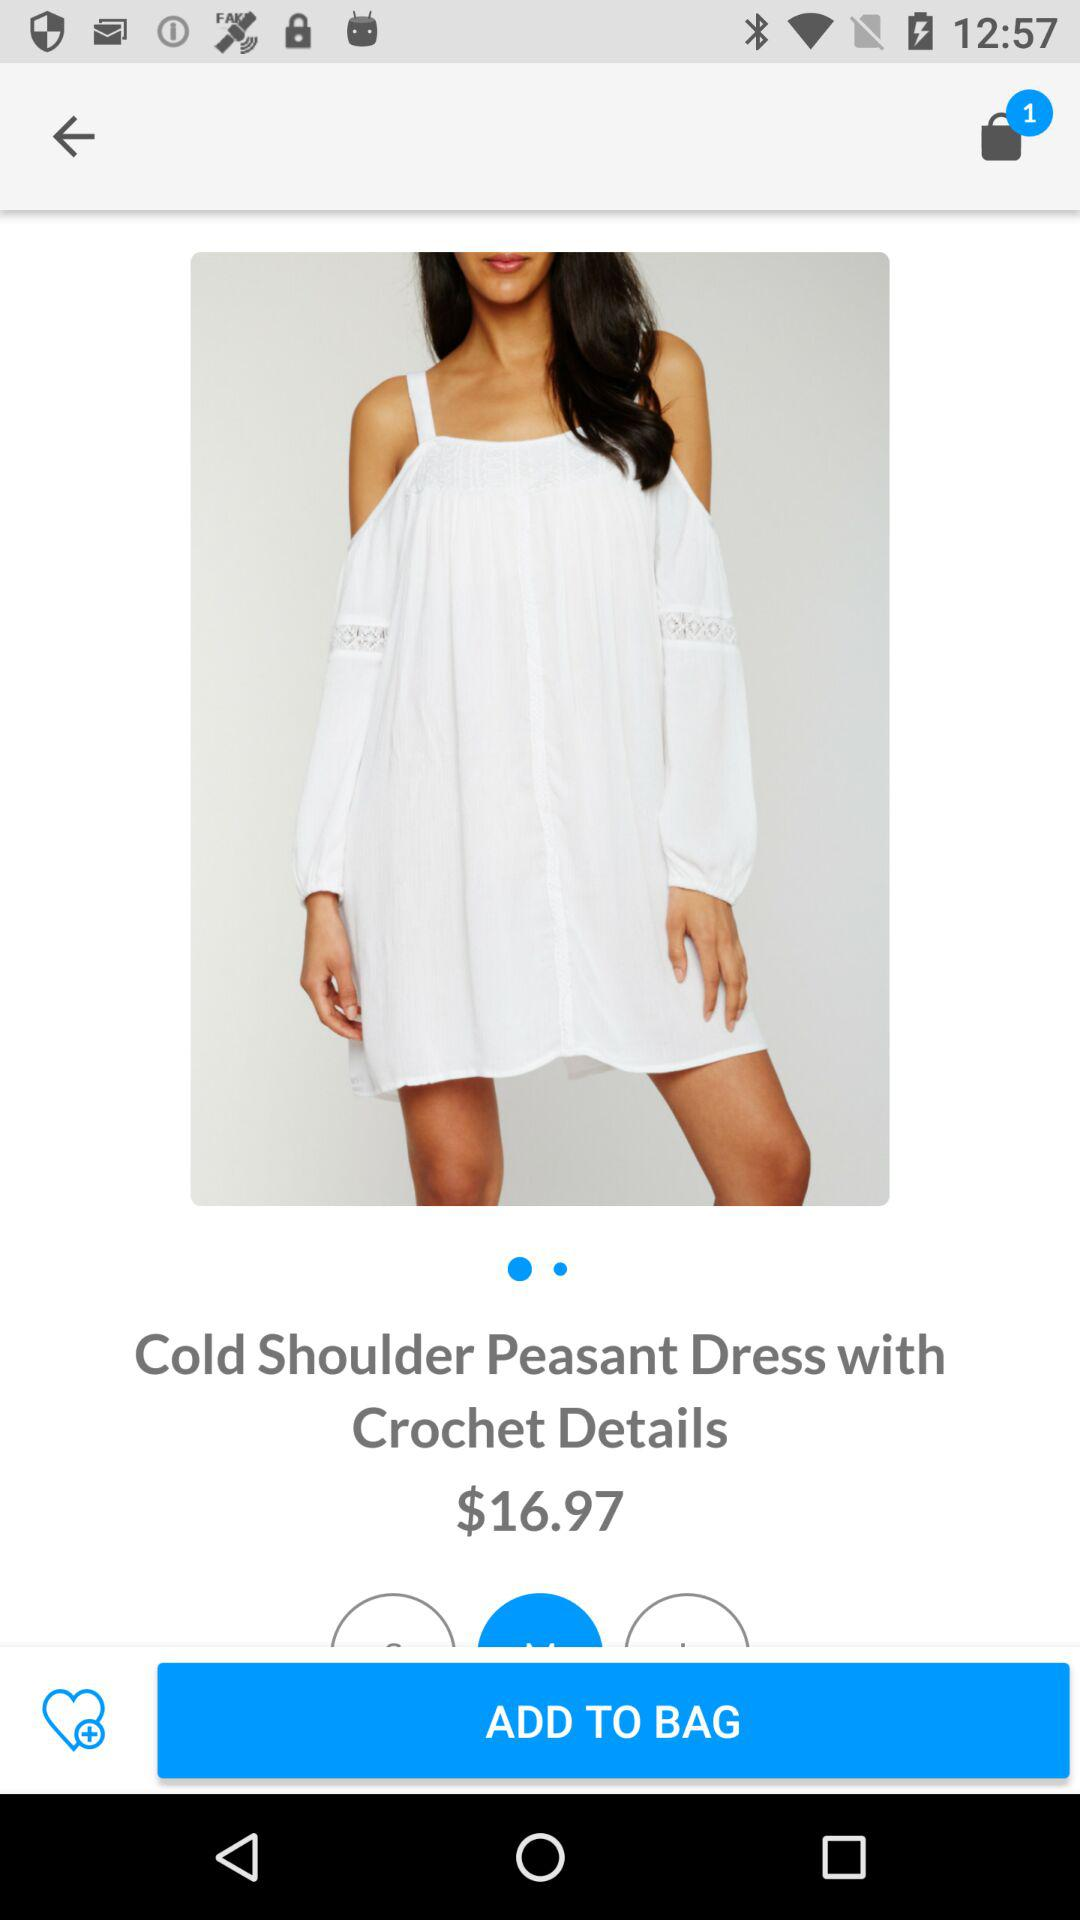What is the name of the product? The name of the product is "Cold Shoulder Peasant Dress with Crochet Details". 